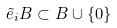Convert formula to latex. <formula><loc_0><loc_0><loc_500><loc_500>\tilde { e } _ { i } B \subset B \cup \{ 0 \}</formula> 